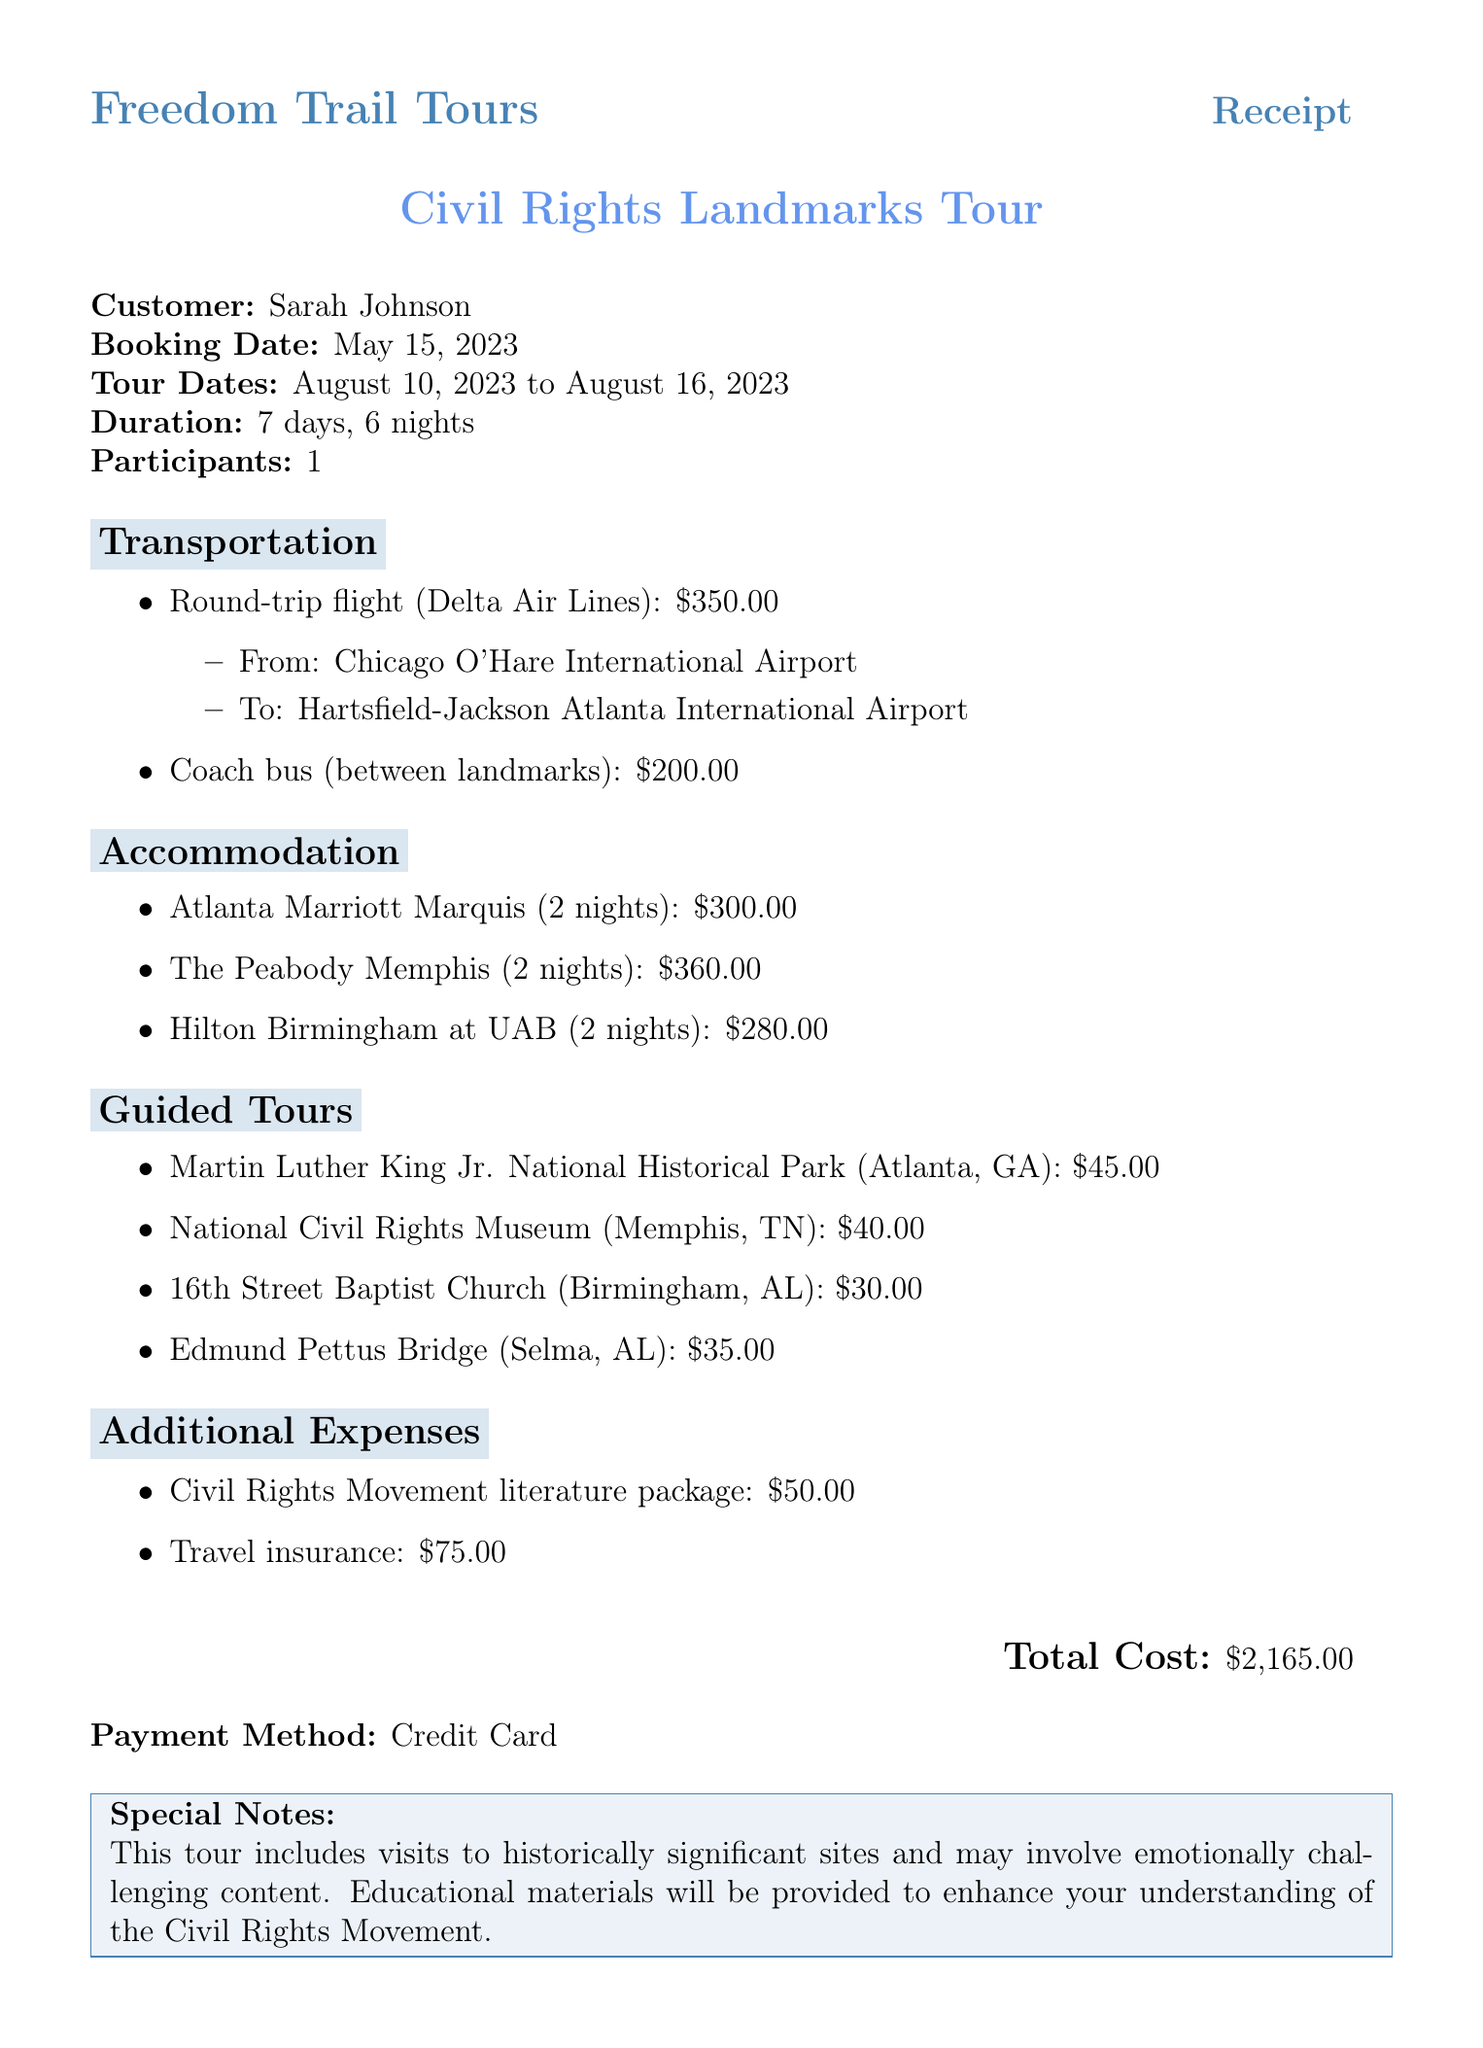What is the travel agency's name? The travel agency's name is explicitly stated at the top of the receipt.
Answer: Freedom Trail Tours Who is the customer? The customer's name is mentioned in the document to indicate who booked the tour.
Answer: Sarah Johnson What are the tour dates? The document specifies the dates during which the tour will take place.
Answer: August 10, 2023 to August 16, 2023 How many nights will the accommodation last? The document states the number of nights included in the tour's accommodation section.
Answer: 6 nights What is the total cost of the tour? The total cost is provided at the end of the receipt, summarizing all expenses.
Answer: $2,165.00 How many guided tours are included in the package? The document lists the guided tours provided during the civil rights landmarks tour.
Answer: 4 guided tours What type of transportation is provided between landmarks? The receipt gives a description of the transportation used for moving between the scheduled locations.
Answer: Coach bus What is the cost of travel insurance? The document itemizes additional expenses, including the cost of travel insurance.
Answer: $75.00 What is the special note in the document? The special note section highlights important information regarding the tour experience.
Answer: This tour includes visits to historically significant sites and may involve emotionally challenging content 